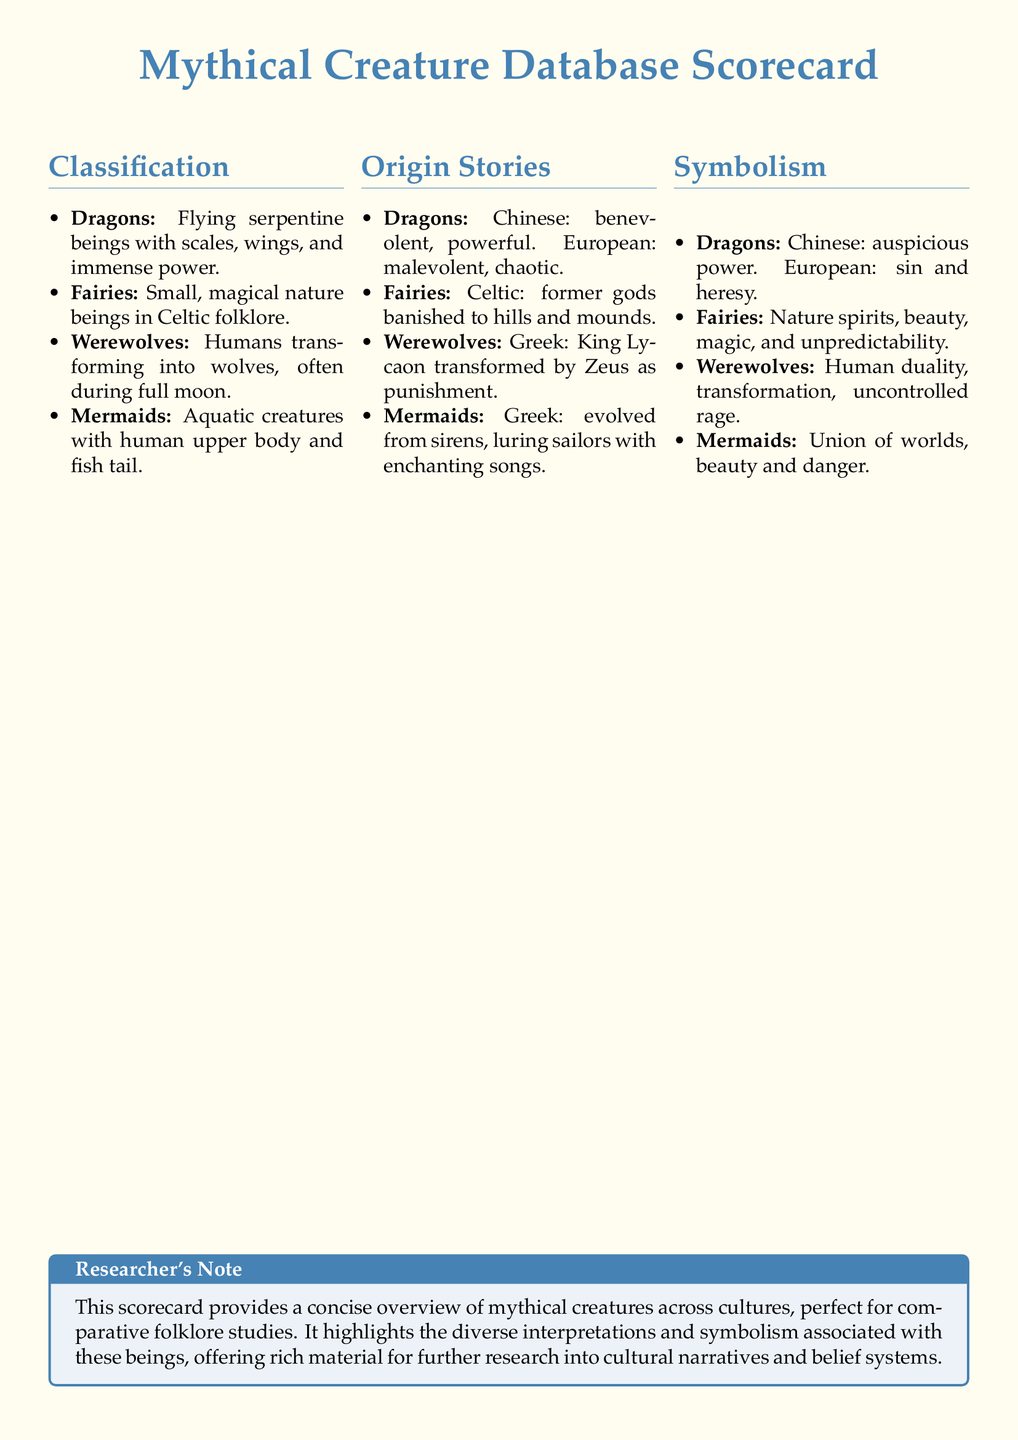What are the four types of mythical creatures listed? The document lists four types of mythical creatures under the Classification section, which are Dragons, Fairies, Werewolves, and Mermaids.
Answer: Dragons, Fairies, Werewolves, Mermaids What is the origin story of Werewolves? The document specifies that the origin story of Werewolves is from Greek mythology where King Lycaon was transformed by Zeus as punishment.
Answer: King Lycaon transformed by Zeus What do dragons symbolize in European folklore? The document indicates that in European folklore, dragons symbolize sin and heresy.
Answer: Sin and heresy How are Fairies characterized in Celtic folklore? The document describes Fairies as small, magical nature beings in Celtic folklore.
Answer: Small, magical nature beings What is the cultural view of Dragons in Chinese folklore? The document states that in Chinese folklore, dragons are seen as benevolent and powerful.
Answer: Benevolent, powerful What do Mermaids represent according to the document? According to the document, Mermaids represent a union of worlds, beauty, and danger.
Answer: Union of worlds, beauty, danger Which mythical creature is associated with human duality? The document mentions that Werewolves are associated with human duality.
Answer: Werewolves What does the Researcher's Note suggest about the scorecard? The Researcher's Note suggests that the scorecard provides a concise overview of mythical creatures across cultures for comparative folklore studies.
Answer: Concise overview for comparative folklore studies 